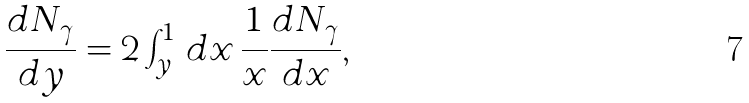<formula> <loc_0><loc_0><loc_500><loc_500>\frac { d N _ { \gamma } } { d y } = 2 \int _ { y } ^ { 1 } \, d x \, \frac { 1 } { x } \frac { d N _ { \gamma } } { d x } ,</formula> 